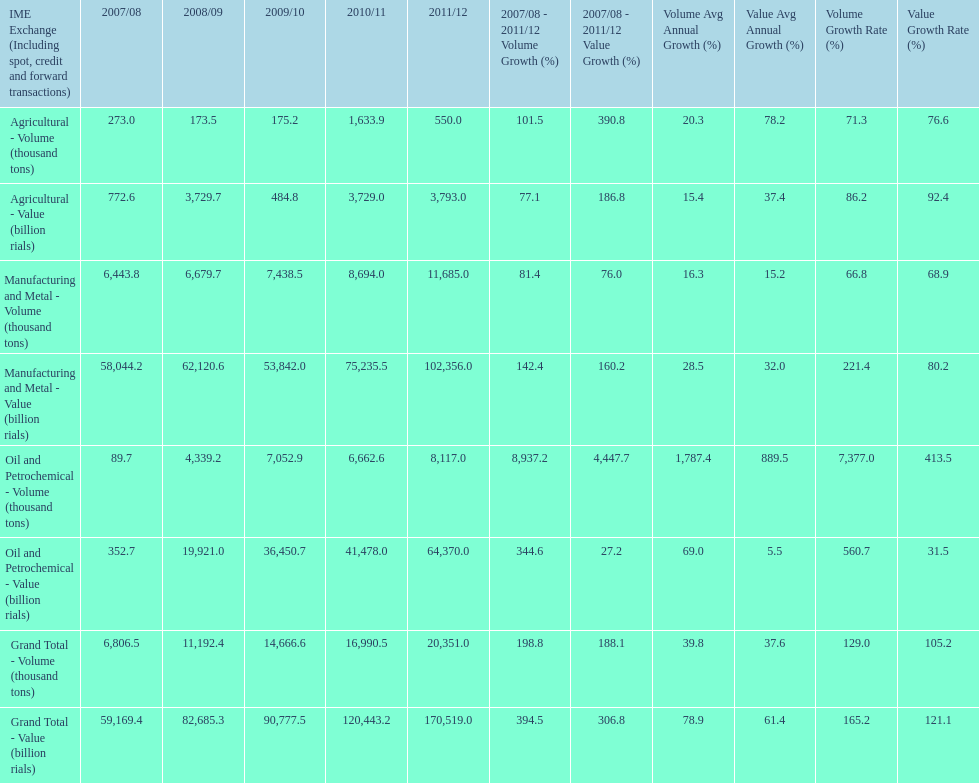What is the total agricultural value in 2008/09? 3,729.7. Give me the full table as a dictionary. {'header': ['IME Exchange (Including spot, credit and forward transactions)', '2007/08', '2008/09', '2009/10', '2010/11', '2011/12', '2007/08 - 2011/12 Volume Growth (%)', '2007/08 - 2011/12 Value Growth (%)', 'Volume Avg Annual Growth (%)', 'Value Avg Annual Growth (%)', 'Volume Growth Rate (%)', 'Value Growth Rate (%)'], 'rows': [['Agricultural - Volume (thousand tons)', '273.0', '173.5', '175.2', '1,633.9', '550.0', '101.5', '390.8', '20.3', '78.2', '71.3', '76.6'], ['Agricultural - Value (billion rials)', '772.6', '3,729.7', '484.8', '3,729.0', '3,793.0', '77.1', '186.8', '15.4', '37.4', '86.2', '92.4'], ['Manufacturing and Metal - Volume (thousand tons)', '6,443.8', '6,679.7', '7,438.5', '8,694.0', '11,685.0', '81.4', '76.0', '16.3', '15.2', '66.8', '68.9'], ['Manufacturing and Metal - Value (billion rials)', '58,044.2', '62,120.6', '53,842.0', '75,235.5', '102,356.0', '142.4', '160.2', '28.5', '32.0', '221.4', '80.2'], ['Oil and Petrochemical - Volume (thousand tons)', '89.7', '4,339.2', '7,052.9', '6,662.6', '8,117.0', '8,937.2', '4,447.7', '1,787.4', '889.5', '7,377.0', '413.5'], ['Oil and Petrochemical - Value (billion rials)', '352.7', '19,921.0', '36,450.7', '41,478.0', '64,370.0', '344.6', '27.2', '69.0', '5.5', '560.7', '31.5'], ['Grand Total - Volume (thousand tons)', '6,806.5', '11,192.4', '14,666.6', '16,990.5', '20,351.0', '198.8', '188.1', '39.8', '37.6', '129.0', '105.2'], ['Grand Total - Value (billion rials)', '59,169.4', '82,685.3', '90,777.5', '120,443.2', '170,519.0', '394.5', '306.8', '78.9', '61.4', '165.2', '121.1']]} 